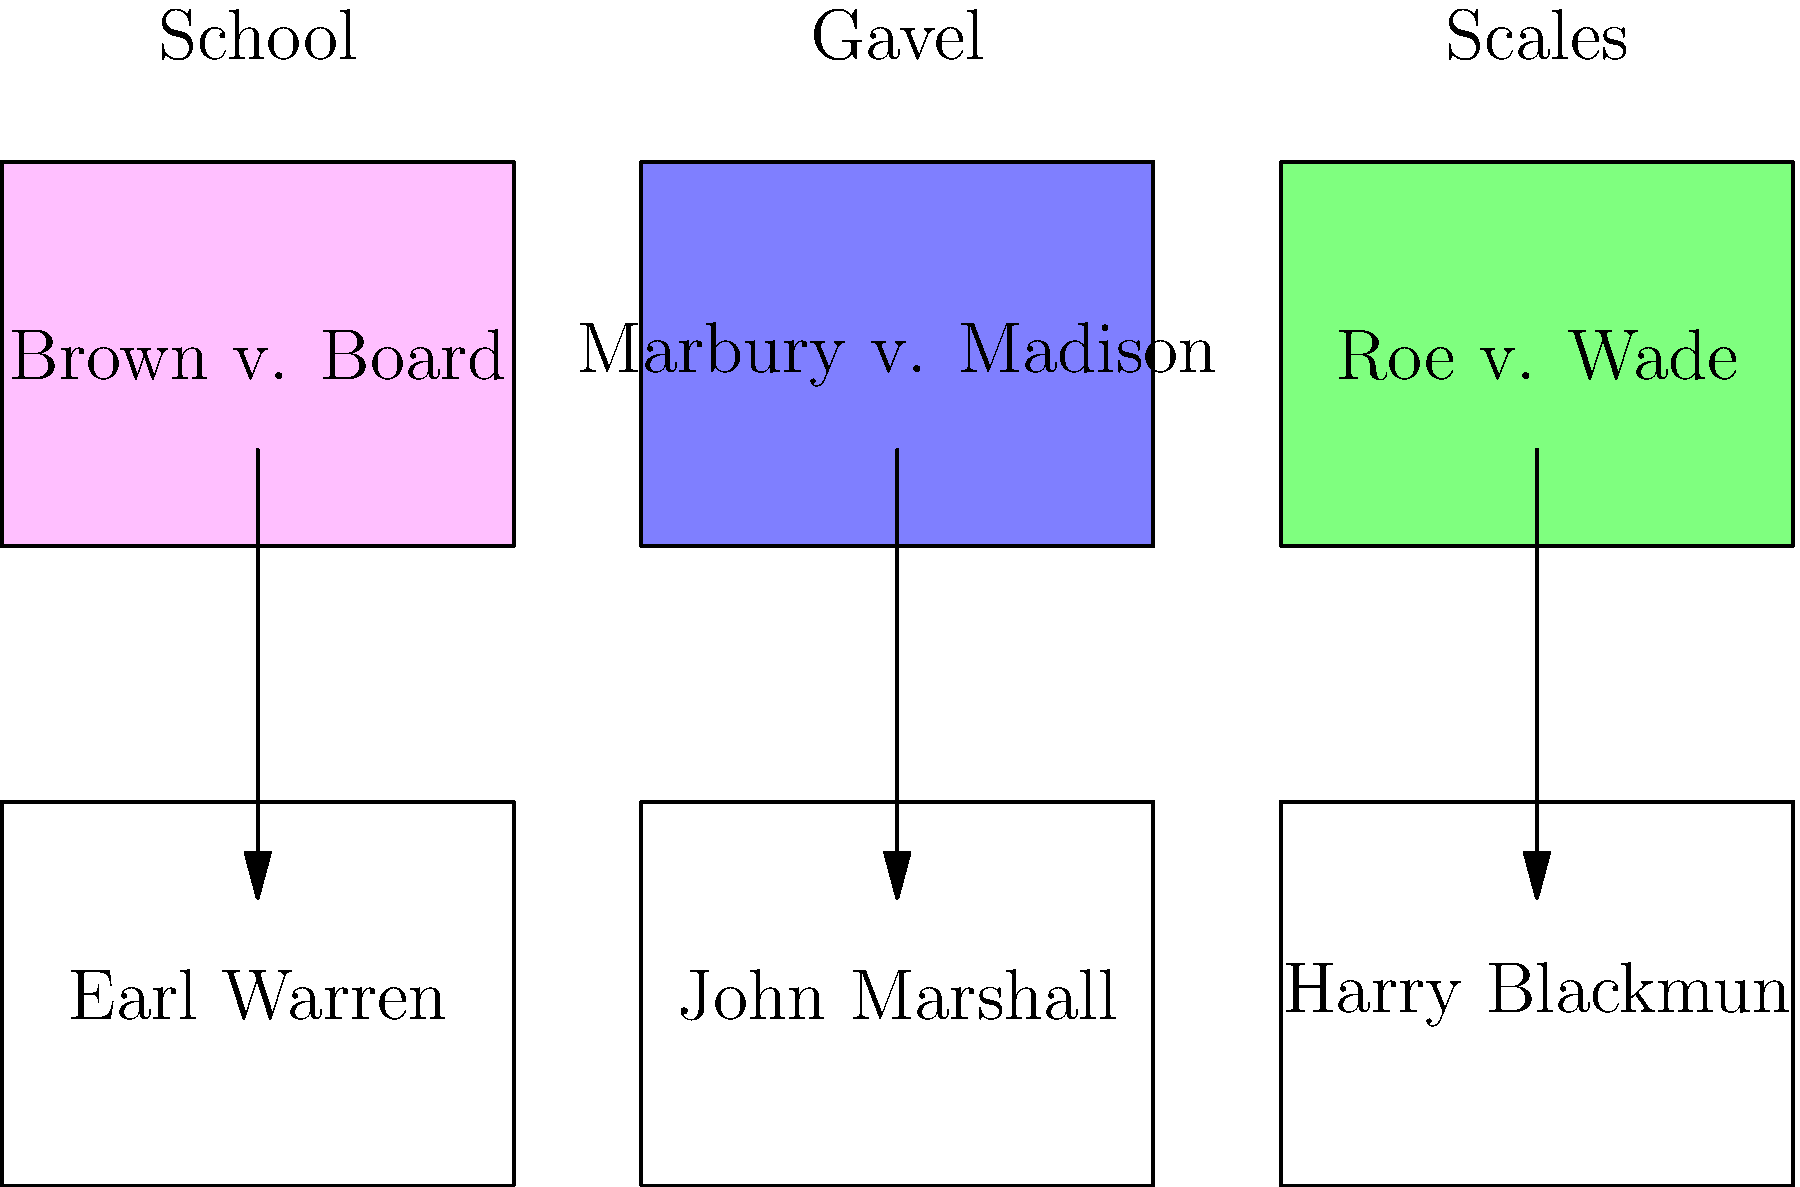Match the Supreme Court Justices to their most famous opinions represented by iconic symbols. Which Justice is correctly paired with their landmark case and corresponding symbol? To solve this puzzle, we need to match each Justice with their most famous opinion and the symbol representing it. Let's analyze each pairing:

1. Earl Warren:
   - Known for: Brown v. Board of Education (1954)
   - Symbol: School (representing desegregation in education)
   - This is a correct match.

2. John Marshall:
   - Known for: Marbury v. Madison (1803)
   - Symbol: Gavel (representing judicial review and the power of the Supreme Court)
   - This is a correct match.

3. Harry Blackmun:
   - Known for: Roe v. Wade (1973)
   - Symbol: Scales (representing the balancing of rights in the abortion debate)
   - This is a correct match.

All three Justices are correctly paired with their landmark cases and corresponding symbols. Each symbol accurately represents the core issue or impact of the respective case:
- The school represents the desegregation of public schools in Brown v. Board of Education.
- The gavel symbolizes the establishment of judicial review in Marbury v. Madison.
- The scales depict the balancing of rights in the abortion debate central to Roe v. Wade.
Answer: All three (Earl Warren, John Marshall, and Harry Blackmun) 